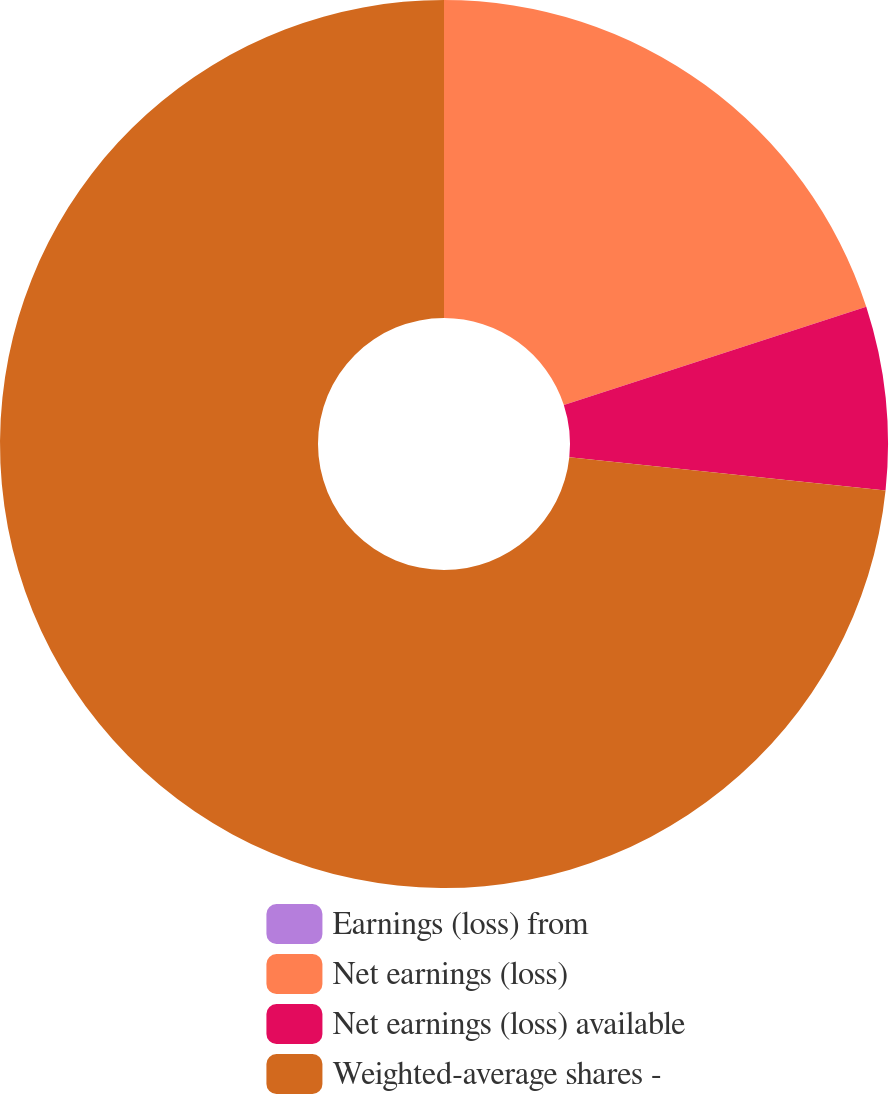<chart> <loc_0><loc_0><loc_500><loc_500><pie_chart><fcel>Earnings (loss) from<fcel>Net earnings (loss)<fcel>Net earnings (loss) available<fcel>Weighted-average shares -<nl><fcel>0.0%<fcel>20.0%<fcel>6.67%<fcel>73.33%<nl></chart> 